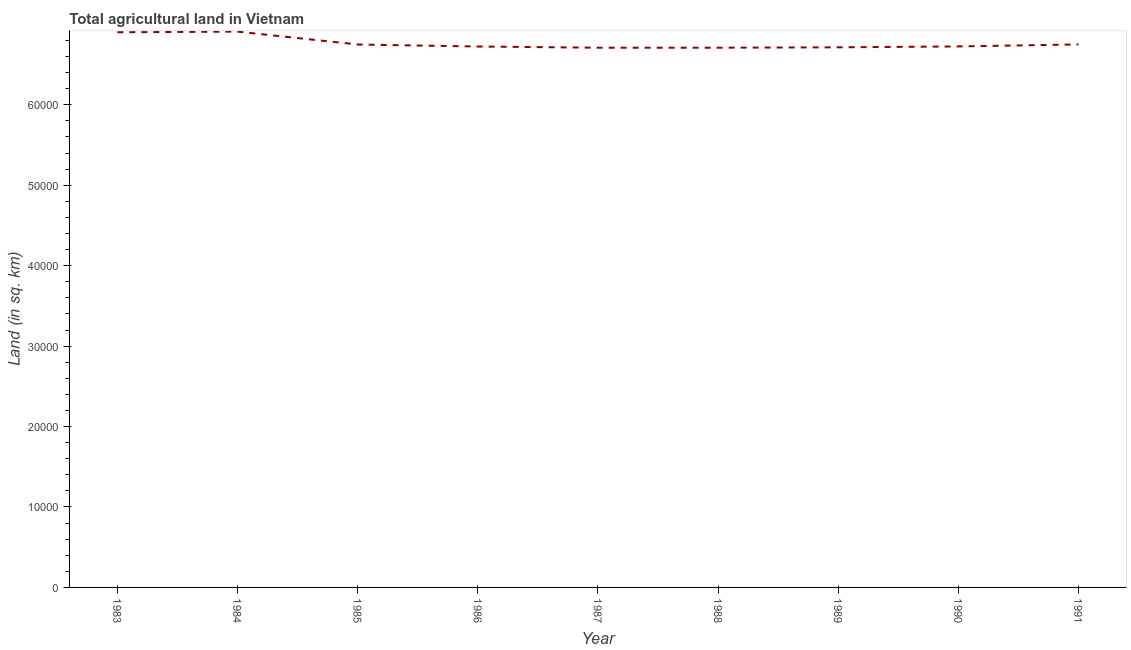What is the agricultural land in 1985?
Give a very brief answer. 6.75e+04. Across all years, what is the maximum agricultural land?
Your answer should be compact. 6.91e+04. Across all years, what is the minimum agricultural land?
Your response must be concise. 6.71e+04. In which year was the agricultural land maximum?
Ensure brevity in your answer.  1984. In which year was the agricultural land minimum?
Keep it short and to the point. 1987. What is the sum of the agricultural land?
Ensure brevity in your answer.  6.09e+05. What is the difference between the agricultural land in 1986 and 1990?
Offer a very short reply. -10. What is the average agricultural land per year?
Provide a succinct answer. 6.77e+04. What is the median agricultural land?
Make the answer very short. 6.73e+04. In how many years, is the agricultural land greater than 50000 sq. km?
Give a very brief answer. 9. Do a majority of the years between 1990 and 1989 (inclusive) have agricultural land greater than 22000 sq. km?
Ensure brevity in your answer.  No. What is the ratio of the agricultural land in 1983 to that in 1984?
Offer a terse response. 1. Is the agricultural land in 1987 less than that in 1991?
Make the answer very short. Yes. What is the difference between the highest and the second highest agricultural land?
Give a very brief answer. 80. What is the difference between the highest and the lowest agricultural land?
Your answer should be very brief. 2000. In how many years, is the agricultural land greater than the average agricultural land taken over all years?
Your answer should be compact. 2. Does the agricultural land monotonically increase over the years?
Provide a short and direct response. No. How many lines are there?
Ensure brevity in your answer.  1. Are the values on the major ticks of Y-axis written in scientific E-notation?
Keep it short and to the point. No. Does the graph contain any zero values?
Ensure brevity in your answer.  No. What is the title of the graph?
Provide a succinct answer. Total agricultural land in Vietnam. What is the label or title of the Y-axis?
Offer a very short reply. Land (in sq. km). What is the Land (in sq. km) in 1983?
Offer a very short reply. 6.90e+04. What is the Land (in sq. km) in 1984?
Keep it short and to the point. 6.91e+04. What is the Land (in sq. km) in 1985?
Your response must be concise. 6.75e+04. What is the Land (in sq. km) in 1986?
Ensure brevity in your answer.  6.72e+04. What is the Land (in sq. km) of 1987?
Your response must be concise. 6.71e+04. What is the Land (in sq. km) of 1988?
Your answer should be very brief. 6.71e+04. What is the Land (in sq. km) in 1989?
Offer a very short reply. 6.72e+04. What is the Land (in sq. km) in 1990?
Your response must be concise. 6.73e+04. What is the Land (in sq. km) of 1991?
Keep it short and to the point. 6.75e+04. What is the difference between the Land (in sq. km) in 1983 and 1984?
Ensure brevity in your answer.  -80. What is the difference between the Land (in sq. km) in 1983 and 1985?
Keep it short and to the point. 1520. What is the difference between the Land (in sq. km) in 1983 and 1986?
Your answer should be very brief. 1770. What is the difference between the Land (in sq. km) in 1983 and 1987?
Give a very brief answer. 1920. What is the difference between the Land (in sq. km) in 1983 and 1988?
Provide a short and direct response. 1920. What is the difference between the Land (in sq. km) in 1983 and 1989?
Provide a short and direct response. 1870. What is the difference between the Land (in sq. km) in 1983 and 1990?
Make the answer very short. 1760. What is the difference between the Land (in sq. km) in 1983 and 1991?
Ensure brevity in your answer.  1510. What is the difference between the Land (in sq. km) in 1984 and 1985?
Your answer should be very brief. 1600. What is the difference between the Land (in sq. km) in 1984 and 1986?
Give a very brief answer. 1850. What is the difference between the Land (in sq. km) in 1984 and 1988?
Give a very brief answer. 2000. What is the difference between the Land (in sq. km) in 1984 and 1989?
Ensure brevity in your answer.  1950. What is the difference between the Land (in sq. km) in 1984 and 1990?
Ensure brevity in your answer.  1840. What is the difference between the Land (in sq. km) in 1984 and 1991?
Give a very brief answer. 1590. What is the difference between the Land (in sq. km) in 1985 and 1986?
Provide a short and direct response. 250. What is the difference between the Land (in sq. km) in 1985 and 1988?
Give a very brief answer. 400. What is the difference between the Land (in sq. km) in 1985 and 1989?
Keep it short and to the point. 350. What is the difference between the Land (in sq. km) in 1985 and 1990?
Offer a terse response. 240. What is the difference between the Land (in sq. km) in 1986 and 1987?
Give a very brief answer. 150. What is the difference between the Land (in sq. km) in 1986 and 1988?
Provide a short and direct response. 150. What is the difference between the Land (in sq. km) in 1986 and 1991?
Offer a terse response. -260. What is the difference between the Land (in sq. km) in 1987 and 1990?
Keep it short and to the point. -160. What is the difference between the Land (in sq. km) in 1987 and 1991?
Ensure brevity in your answer.  -410. What is the difference between the Land (in sq. km) in 1988 and 1990?
Offer a very short reply. -160. What is the difference between the Land (in sq. km) in 1988 and 1991?
Your answer should be very brief. -410. What is the difference between the Land (in sq. km) in 1989 and 1990?
Provide a short and direct response. -110. What is the difference between the Land (in sq. km) in 1989 and 1991?
Your response must be concise. -360. What is the difference between the Land (in sq. km) in 1990 and 1991?
Your response must be concise. -250. What is the ratio of the Land (in sq. km) in 1983 to that in 1984?
Ensure brevity in your answer.  1. What is the ratio of the Land (in sq. km) in 1983 to that in 1987?
Provide a short and direct response. 1.03. What is the ratio of the Land (in sq. km) in 1983 to that in 1988?
Keep it short and to the point. 1.03. What is the ratio of the Land (in sq. km) in 1983 to that in 1989?
Provide a succinct answer. 1.03. What is the ratio of the Land (in sq. km) in 1983 to that in 1991?
Make the answer very short. 1.02. What is the ratio of the Land (in sq. km) in 1984 to that in 1985?
Provide a succinct answer. 1.02. What is the ratio of the Land (in sq. km) in 1984 to that in 1986?
Make the answer very short. 1.03. What is the ratio of the Land (in sq. km) in 1984 to that in 1988?
Your answer should be very brief. 1.03. What is the ratio of the Land (in sq. km) in 1984 to that in 1991?
Give a very brief answer. 1.02. What is the ratio of the Land (in sq. km) in 1985 to that in 1986?
Provide a short and direct response. 1. What is the ratio of the Land (in sq. km) in 1985 to that in 1987?
Your answer should be very brief. 1.01. What is the ratio of the Land (in sq. km) in 1985 to that in 1988?
Give a very brief answer. 1.01. What is the ratio of the Land (in sq. km) in 1986 to that in 1987?
Keep it short and to the point. 1. What is the ratio of the Land (in sq. km) in 1986 to that in 1990?
Offer a terse response. 1. What is the ratio of the Land (in sq. km) in 1986 to that in 1991?
Provide a short and direct response. 1. What is the ratio of the Land (in sq. km) in 1987 to that in 1988?
Ensure brevity in your answer.  1. What is the ratio of the Land (in sq. km) in 1987 to that in 1989?
Your response must be concise. 1. What is the ratio of the Land (in sq. km) in 1987 to that in 1991?
Provide a short and direct response. 0.99. What is the ratio of the Land (in sq. km) in 1988 to that in 1989?
Give a very brief answer. 1. What is the ratio of the Land (in sq. km) in 1988 to that in 1991?
Provide a short and direct response. 0.99. What is the ratio of the Land (in sq. km) in 1989 to that in 1991?
Make the answer very short. 0.99. 